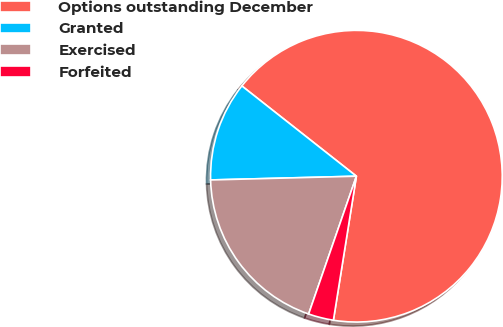Convert chart to OTSL. <chart><loc_0><loc_0><loc_500><loc_500><pie_chart><fcel>Options outstanding December<fcel>Granted<fcel>Exercised<fcel>Forfeited<nl><fcel>66.9%<fcel>11.03%<fcel>19.28%<fcel>2.79%<nl></chart> 